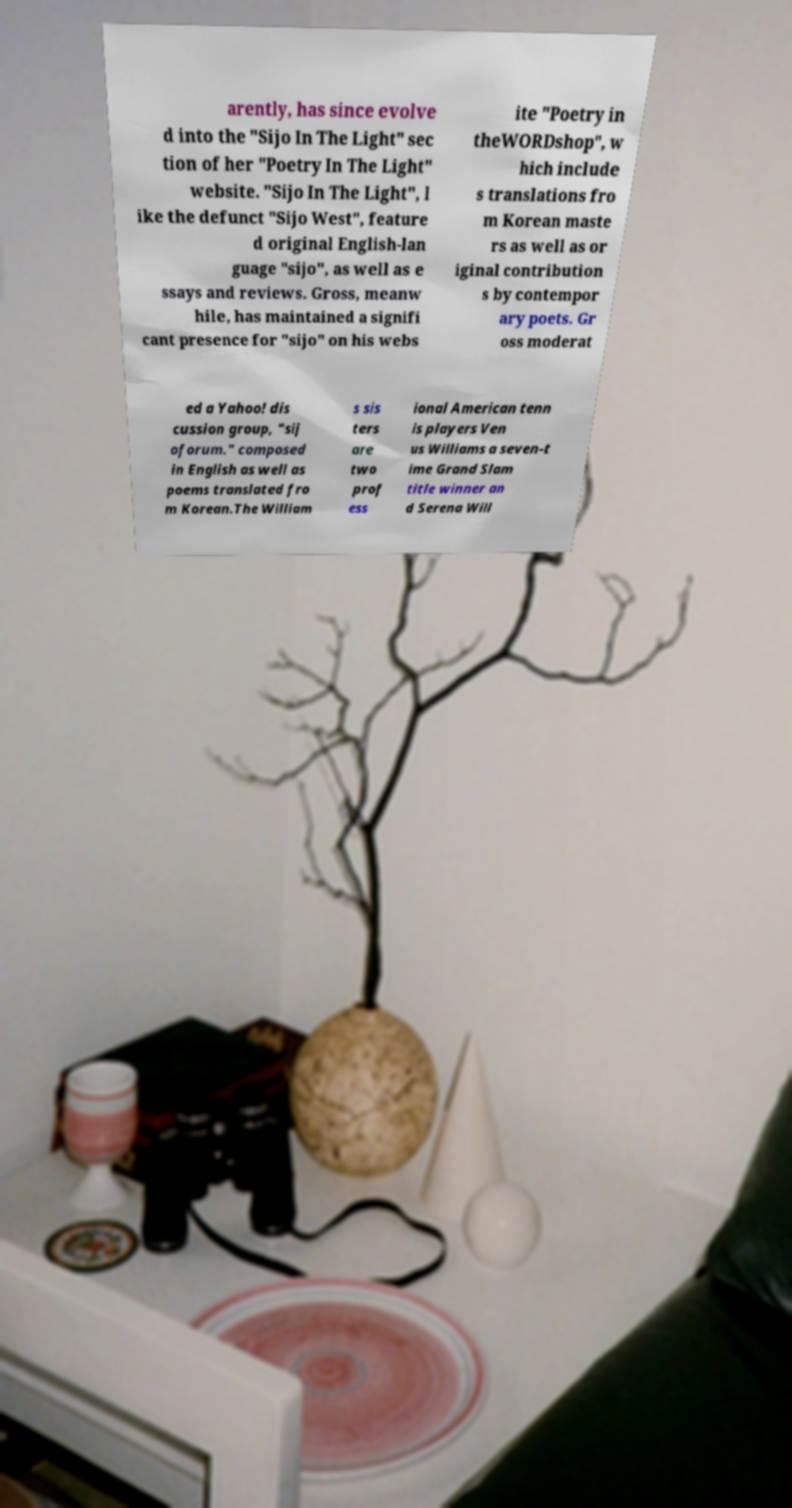What messages or text are displayed in this image? I need them in a readable, typed format. arently, has since evolve d into the "Sijo In The Light" sec tion of her "Poetry In The Light" website. "Sijo In The Light", l ike the defunct "Sijo West", feature d original English-lan guage "sijo", as well as e ssays and reviews. Gross, meanw hile, has maintained a signifi cant presence for "sijo" on his webs ite "Poetry in theWORDshop", w hich include s translations fro m Korean maste rs as well as or iginal contribution s by contempor ary poets. Gr oss moderat ed a Yahoo! dis cussion group, "sij oforum." composed in English as well as poems translated fro m Korean.The William s sis ters are two prof ess ional American tenn is players Ven us Williams a seven-t ime Grand Slam title winner an d Serena Will 